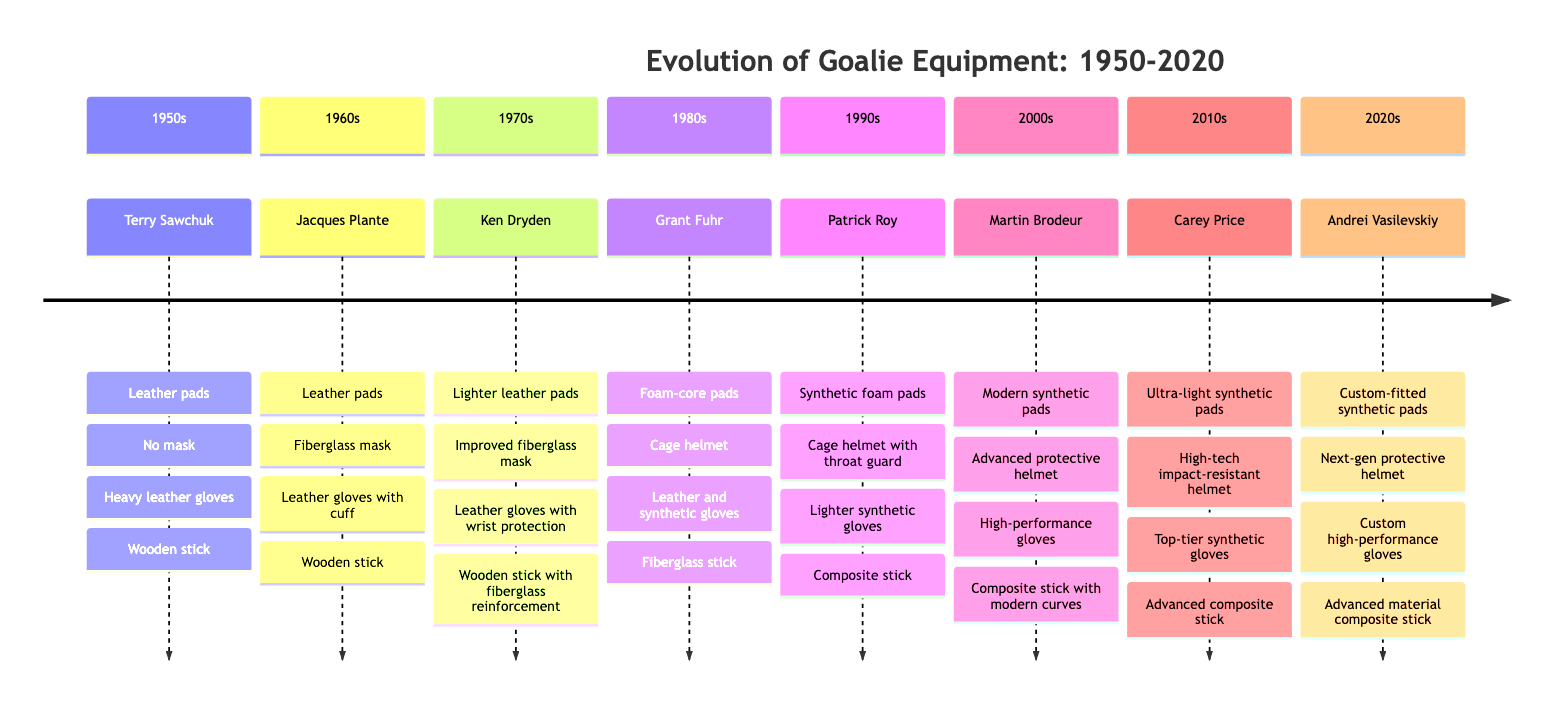What type of pads did Terry Sawchuk use? According to the diagram, Terry Sawchuk used leather pads in the 1950s.
Answer: Leather pads In which decade did Patrick Roy use composite sticks? The diagram shows that Patrick Roy used composite sticks in the 1990s.
Answer: 1990s Which goaltender was associated with a cage helmet in the 1980s? The diagram indicates that Grant Fuhr used a cage helmet in the 1980s.
Answer: Grant Fuhr What is the progression of mask types from the 1950s to the 1990s? Reviewing the diagram, the mask types progressed from no mask (1950s), to fiberglass mask (1960s), to improved fiberglass mask (1970s), to cage helmet (1980s), and finally to cage helmet with throat guard (1990s).
Answer: No mask, fiberglass mask, improved fiberglass mask, cage helmet, cage helmet with throat guard Which decade featured the use of custom-fitted synthetic pads? Referring to the diagram, custom-fitted synthetic pads were used in the 2020s by Andrei Vasilevskiy.
Answer: 2020s How many different stick types appear in the diagram? The diagram lists four types of sticks: wooden stick, wooden stick with fiberglass reinforcement, fiberglass stick, and composite stick. Hence, counting these gives a total of four different stick types.
Answer: 4 Which goaltender was the first to use synthetic foam pads? The diagram indicates that Patrick Roy was the first goaltender shown using synthetic foam pads in the 1990s.
Answer: Patrick Roy What year did ultra-light synthetic pads first appear? The diagram shows that ultra-light synthetic pads were first used in the 2010s by Carey Price.
Answer: 2010s Which piece of equipment saw the greatest technological advancement from the 1950s to the 2020s? The diagram illustrates that the helmet evolved from no mask in the 1950s to a next-gen protective helmet in the 2020s, demonstrating significant advancement over the decades.
Answer: Helmet 